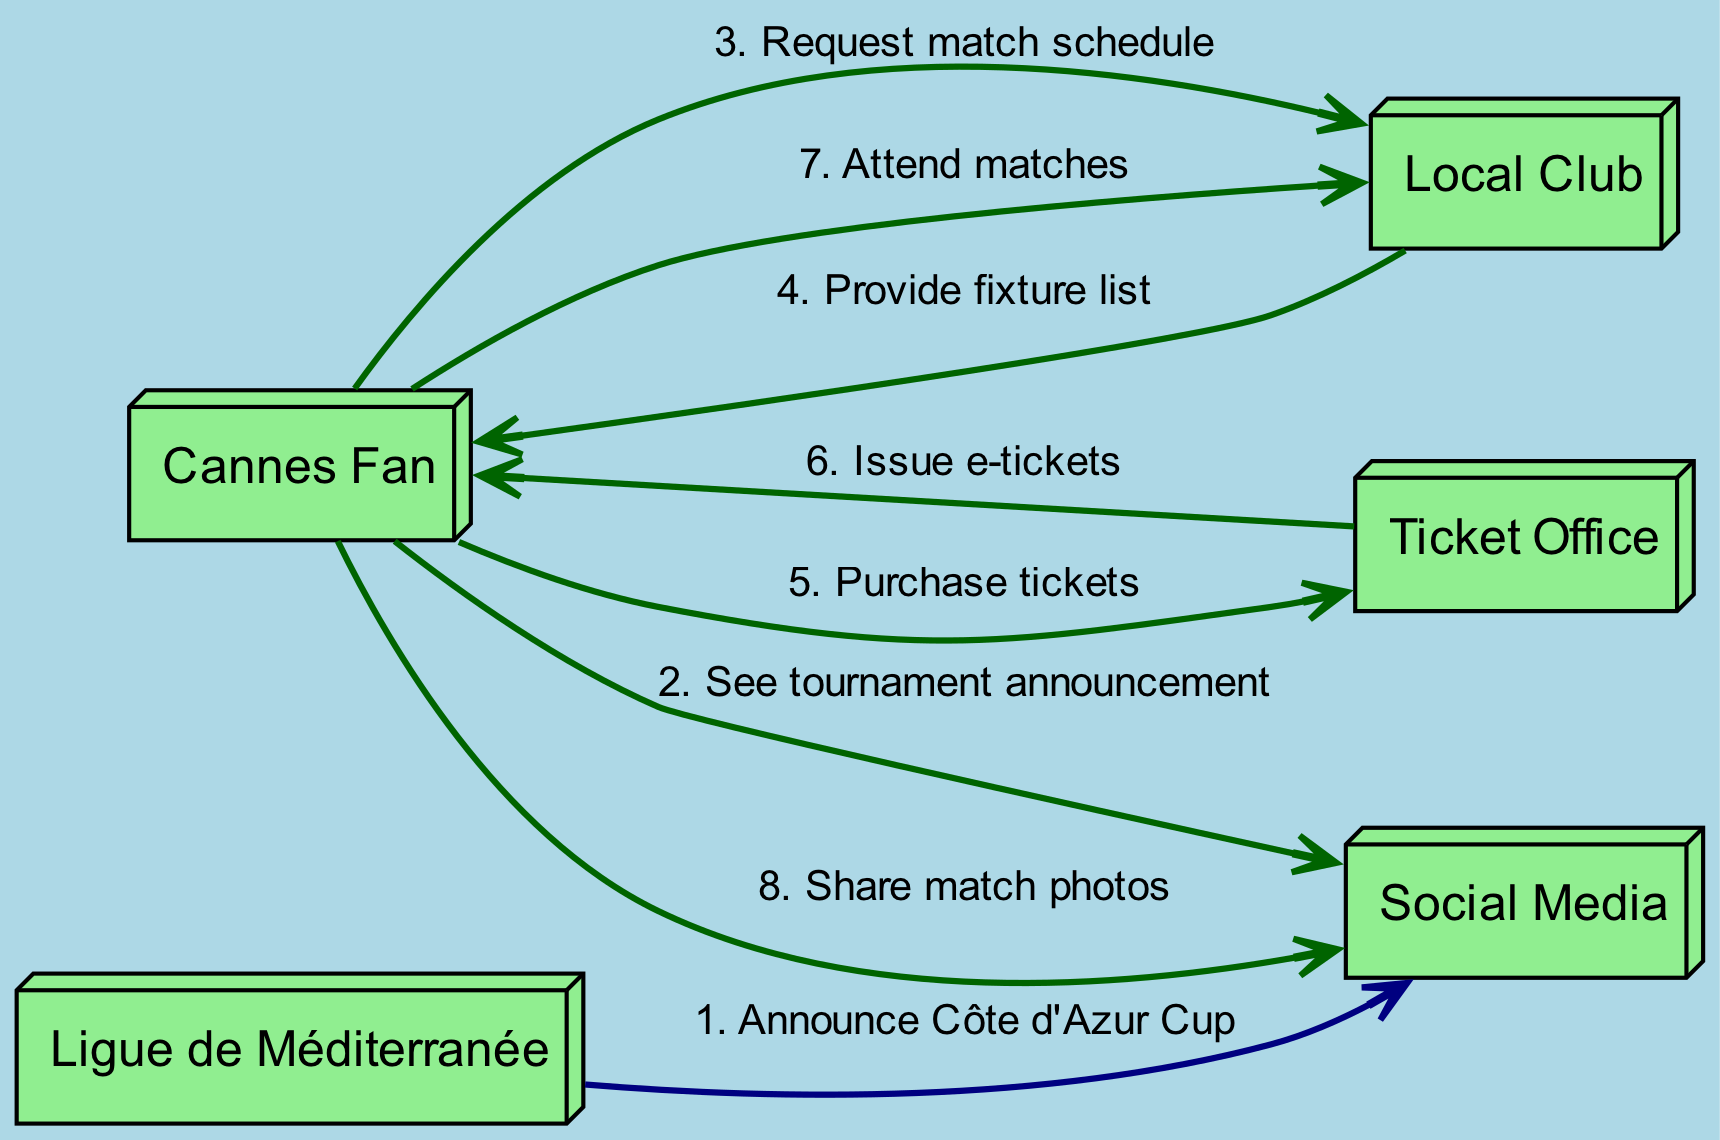What action does the Ligue de Méditerranée perform first? The first action in the sequence diagram is from the Ligue de Méditerranée to Social Media, where it announces the Côte d'Azur Cup.
Answer: Announce Côte d'Azur Cup How many nodes are present in the diagram? The nodes include five actors: Cannes Fan, Ligue de Méditerranée, Local Club, Social Media, and Ticket Office. This totals to five nodes.
Answer: 5 What is the last action taken by the Cannes Fan in the sequence? The last action taken by the Cannes Fan is to share match photos on Social Media.
Answer: Share match photos Which actor provides the fixture list to the Cannes Fan? The Local Club provides the fixture list to the Cannes Fan following the request.
Answer: Local Club What is the total number of actions represented in the diagram? The diagram contains a total of eight actions from the sequence illustrating the fan engagement journey.
Answer: 8 Who issues the e-tickets to the Cannes Fan? The Ticket Office is responsible for issuing e-tickets to the Cannes Fan after the purchase is made.
Answer: Ticket Office What type of relationship exists between the Cannes Fan and the Local Club? There are multiple interactions where the Cannes Fan requests information and attends matches related to the Local Club, showing a participatory relationship.
Answer: Participatory Which social media activity does the Cannes Fan engage in after attending matches? After attending matches, the Cannes Fan shares match photos on Social Media, emphasizing fan engagement beyond just attendance.
Answer: Share match photos 